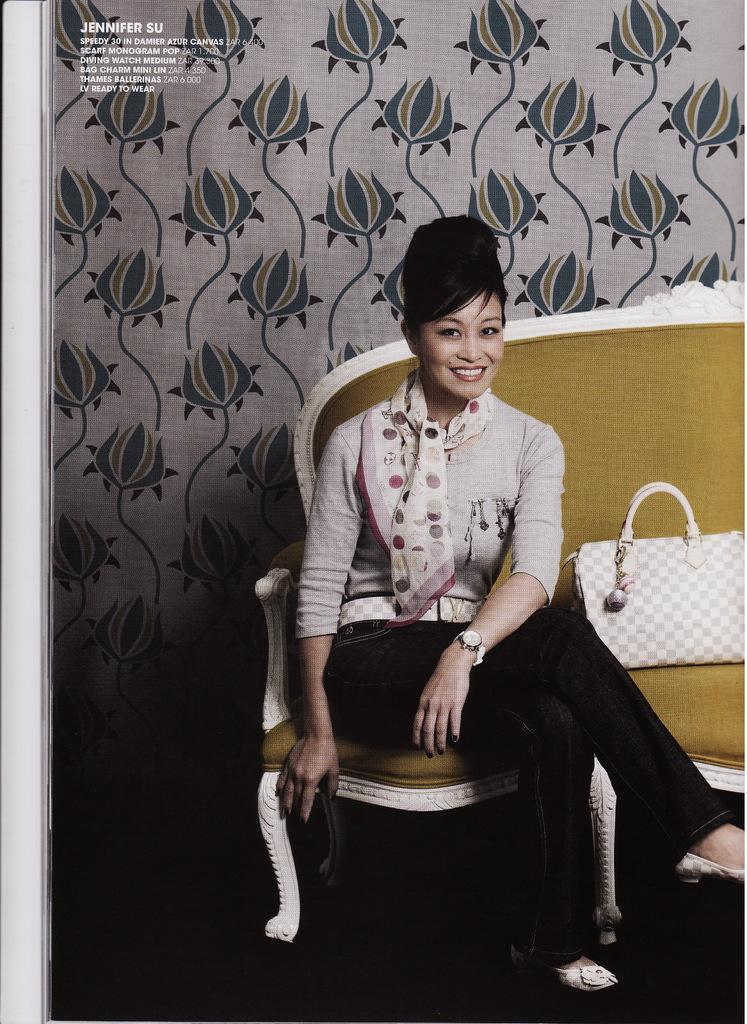Who is present in the image? There is a woman in the image. What is the woman doing in the image? The woman is sitting on a couch. What color is the woman's handbag? The woman has a white-colored handbag. What accessory is the woman wearing in the image? The woman is wearing a white-colored scarf. What can be seen in the background of the image? There is a wallpaper in the background of the image. How many sheep are visible in the image? There are no sheep present in the image. What is the mass of the boundary in the image? There is no boundary present in the image, and therefore no mass can be determined. 